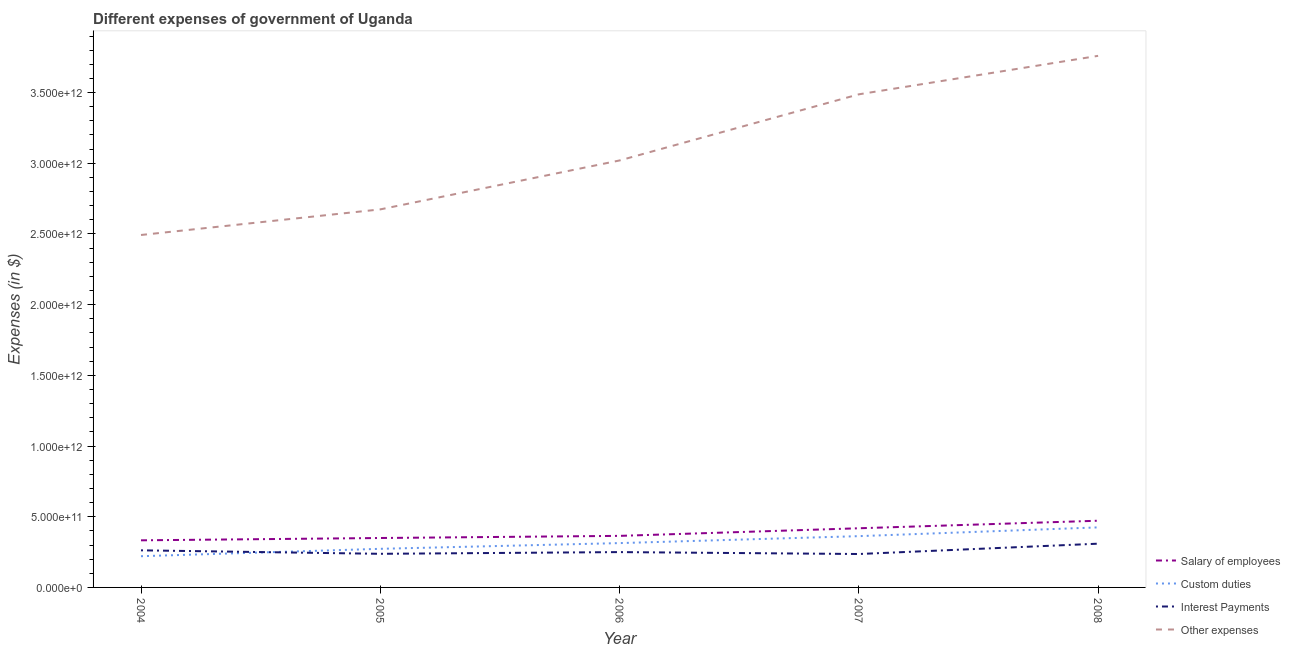How many different coloured lines are there?
Give a very brief answer. 4. Does the line corresponding to amount spent on salary of employees intersect with the line corresponding to amount spent on interest payments?
Your answer should be compact. No. What is the amount spent on other expenses in 2008?
Ensure brevity in your answer.  3.76e+12. Across all years, what is the maximum amount spent on other expenses?
Provide a succinct answer. 3.76e+12. Across all years, what is the minimum amount spent on custom duties?
Your answer should be very brief. 2.21e+11. In which year was the amount spent on salary of employees maximum?
Offer a very short reply. 2008. In which year was the amount spent on other expenses minimum?
Give a very brief answer. 2004. What is the total amount spent on salary of employees in the graph?
Ensure brevity in your answer.  1.94e+12. What is the difference between the amount spent on salary of employees in 2006 and that in 2008?
Offer a very short reply. -1.07e+11. What is the difference between the amount spent on custom duties in 2006 and the amount spent on other expenses in 2005?
Your answer should be very brief. -2.36e+12. What is the average amount spent on salary of employees per year?
Provide a short and direct response. 3.88e+11. In the year 2005, what is the difference between the amount spent on interest payments and amount spent on other expenses?
Ensure brevity in your answer.  -2.44e+12. In how many years, is the amount spent on interest payments greater than 700000000000 $?
Offer a terse response. 0. What is the ratio of the amount spent on interest payments in 2004 to that in 2005?
Your answer should be very brief. 1.1. Is the amount spent on other expenses in 2004 less than that in 2005?
Ensure brevity in your answer.  Yes. What is the difference between the highest and the second highest amount spent on interest payments?
Provide a short and direct response. 4.70e+1. What is the difference between the highest and the lowest amount spent on custom duties?
Make the answer very short. 2.04e+11. In how many years, is the amount spent on custom duties greater than the average amount spent on custom duties taken over all years?
Ensure brevity in your answer.  2. Is it the case that in every year, the sum of the amount spent on custom duties and amount spent on other expenses is greater than the sum of amount spent on interest payments and amount spent on salary of employees?
Keep it short and to the point. Yes. Does the amount spent on custom duties monotonically increase over the years?
Your answer should be compact. Yes. Is the amount spent on custom duties strictly greater than the amount spent on other expenses over the years?
Give a very brief answer. No. Is the amount spent on interest payments strictly less than the amount spent on other expenses over the years?
Provide a succinct answer. Yes. How many lines are there?
Offer a terse response. 4. How many years are there in the graph?
Make the answer very short. 5. What is the difference between two consecutive major ticks on the Y-axis?
Make the answer very short. 5.00e+11. Are the values on the major ticks of Y-axis written in scientific E-notation?
Your response must be concise. Yes. Does the graph contain any zero values?
Your answer should be very brief. No. Where does the legend appear in the graph?
Offer a terse response. Bottom right. How are the legend labels stacked?
Your answer should be very brief. Vertical. What is the title of the graph?
Give a very brief answer. Different expenses of government of Uganda. What is the label or title of the X-axis?
Your response must be concise. Year. What is the label or title of the Y-axis?
Offer a terse response. Expenses (in $). What is the Expenses (in $) in Salary of employees in 2004?
Offer a terse response. 3.33e+11. What is the Expenses (in $) of Custom duties in 2004?
Give a very brief answer. 2.21e+11. What is the Expenses (in $) of Interest Payments in 2004?
Give a very brief answer. 2.62e+11. What is the Expenses (in $) of Other expenses in 2004?
Ensure brevity in your answer.  2.49e+12. What is the Expenses (in $) in Salary of employees in 2005?
Ensure brevity in your answer.  3.50e+11. What is the Expenses (in $) of Custom duties in 2005?
Your answer should be very brief. 2.73e+11. What is the Expenses (in $) of Interest Payments in 2005?
Ensure brevity in your answer.  2.38e+11. What is the Expenses (in $) of Other expenses in 2005?
Your answer should be compact. 2.67e+12. What is the Expenses (in $) of Salary of employees in 2006?
Your answer should be very brief. 3.65e+11. What is the Expenses (in $) of Custom duties in 2006?
Ensure brevity in your answer.  3.14e+11. What is the Expenses (in $) of Interest Payments in 2006?
Your answer should be compact. 2.50e+11. What is the Expenses (in $) of Other expenses in 2006?
Offer a terse response. 3.02e+12. What is the Expenses (in $) of Salary of employees in 2007?
Your answer should be compact. 4.18e+11. What is the Expenses (in $) of Custom duties in 2007?
Offer a terse response. 3.63e+11. What is the Expenses (in $) in Interest Payments in 2007?
Your answer should be compact. 2.36e+11. What is the Expenses (in $) of Other expenses in 2007?
Give a very brief answer. 3.49e+12. What is the Expenses (in $) in Salary of employees in 2008?
Your response must be concise. 4.72e+11. What is the Expenses (in $) of Custom duties in 2008?
Offer a very short reply. 4.25e+11. What is the Expenses (in $) in Interest Payments in 2008?
Your response must be concise. 3.09e+11. What is the Expenses (in $) of Other expenses in 2008?
Ensure brevity in your answer.  3.76e+12. Across all years, what is the maximum Expenses (in $) of Salary of employees?
Keep it short and to the point. 4.72e+11. Across all years, what is the maximum Expenses (in $) in Custom duties?
Ensure brevity in your answer.  4.25e+11. Across all years, what is the maximum Expenses (in $) of Interest Payments?
Give a very brief answer. 3.09e+11. Across all years, what is the maximum Expenses (in $) in Other expenses?
Offer a terse response. 3.76e+12. Across all years, what is the minimum Expenses (in $) of Salary of employees?
Make the answer very short. 3.33e+11. Across all years, what is the minimum Expenses (in $) of Custom duties?
Ensure brevity in your answer.  2.21e+11. Across all years, what is the minimum Expenses (in $) of Interest Payments?
Offer a terse response. 2.36e+11. Across all years, what is the minimum Expenses (in $) in Other expenses?
Keep it short and to the point. 2.49e+12. What is the total Expenses (in $) in Salary of employees in the graph?
Ensure brevity in your answer.  1.94e+12. What is the total Expenses (in $) in Custom duties in the graph?
Provide a succinct answer. 1.59e+12. What is the total Expenses (in $) of Interest Payments in the graph?
Provide a short and direct response. 1.30e+12. What is the total Expenses (in $) of Other expenses in the graph?
Offer a terse response. 1.54e+13. What is the difference between the Expenses (in $) of Salary of employees in 2004 and that in 2005?
Your answer should be compact. -1.64e+1. What is the difference between the Expenses (in $) of Custom duties in 2004 and that in 2005?
Your response must be concise. -5.22e+1. What is the difference between the Expenses (in $) of Interest Payments in 2004 and that in 2005?
Make the answer very short. 2.46e+1. What is the difference between the Expenses (in $) of Other expenses in 2004 and that in 2005?
Offer a very short reply. -1.81e+11. What is the difference between the Expenses (in $) in Salary of employees in 2004 and that in 2006?
Keep it short and to the point. -3.15e+1. What is the difference between the Expenses (in $) of Custom duties in 2004 and that in 2006?
Provide a succinct answer. -9.27e+1. What is the difference between the Expenses (in $) of Interest Payments in 2004 and that in 2006?
Provide a succinct answer. 1.25e+1. What is the difference between the Expenses (in $) of Other expenses in 2004 and that in 2006?
Offer a terse response. -5.27e+11. What is the difference between the Expenses (in $) in Salary of employees in 2004 and that in 2007?
Offer a very short reply. -8.53e+1. What is the difference between the Expenses (in $) of Custom duties in 2004 and that in 2007?
Keep it short and to the point. -1.42e+11. What is the difference between the Expenses (in $) of Interest Payments in 2004 and that in 2007?
Your answer should be very brief. 2.61e+1. What is the difference between the Expenses (in $) in Other expenses in 2004 and that in 2007?
Your answer should be very brief. -9.95e+11. What is the difference between the Expenses (in $) of Salary of employees in 2004 and that in 2008?
Provide a succinct answer. -1.39e+11. What is the difference between the Expenses (in $) of Custom duties in 2004 and that in 2008?
Give a very brief answer. -2.04e+11. What is the difference between the Expenses (in $) in Interest Payments in 2004 and that in 2008?
Make the answer very short. -4.70e+1. What is the difference between the Expenses (in $) of Other expenses in 2004 and that in 2008?
Keep it short and to the point. -1.27e+12. What is the difference between the Expenses (in $) in Salary of employees in 2005 and that in 2006?
Give a very brief answer. -1.51e+1. What is the difference between the Expenses (in $) in Custom duties in 2005 and that in 2006?
Offer a very short reply. -4.04e+1. What is the difference between the Expenses (in $) of Interest Payments in 2005 and that in 2006?
Your answer should be very brief. -1.21e+1. What is the difference between the Expenses (in $) in Other expenses in 2005 and that in 2006?
Give a very brief answer. -3.46e+11. What is the difference between the Expenses (in $) of Salary of employees in 2005 and that in 2007?
Offer a very short reply. -6.89e+1. What is the difference between the Expenses (in $) in Custom duties in 2005 and that in 2007?
Offer a terse response. -8.96e+1. What is the difference between the Expenses (in $) in Interest Payments in 2005 and that in 2007?
Ensure brevity in your answer.  1.43e+09. What is the difference between the Expenses (in $) in Other expenses in 2005 and that in 2007?
Offer a very short reply. -8.14e+11. What is the difference between the Expenses (in $) of Salary of employees in 2005 and that in 2008?
Your answer should be compact. -1.22e+11. What is the difference between the Expenses (in $) in Custom duties in 2005 and that in 2008?
Keep it short and to the point. -1.52e+11. What is the difference between the Expenses (in $) of Interest Payments in 2005 and that in 2008?
Your answer should be very brief. -7.16e+1. What is the difference between the Expenses (in $) in Other expenses in 2005 and that in 2008?
Give a very brief answer. -1.09e+12. What is the difference between the Expenses (in $) in Salary of employees in 2006 and that in 2007?
Provide a succinct answer. -5.38e+1. What is the difference between the Expenses (in $) of Custom duties in 2006 and that in 2007?
Your response must be concise. -4.91e+1. What is the difference between the Expenses (in $) in Interest Payments in 2006 and that in 2007?
Provide a succinct answer. 1.36e+1. What is the difference between the Expenses (in $) in Other expenses in 2006 and that in 2007?
Give a very brief answer. -4.68e+11. What is the difference between the Expenses (in $) of Salary of employees in 2006 and that in 2008?
Make the answer very short. -1.07e+11. What is the difference between the Expenses (in $) in Custom duties in 2006 and that in 2008?
Your answer should be compact. -1.11e+11. What is the difference between the Expenses (in $) in Interest Payments in 2006 and that in 2008?
Your response must be concise. -5.95e+1. What is the difference between the Expenses (in $) of Other expenses in 2006 and that in 2008?
Provide a short and direct response. -7.40e+11. What is the difference between the Expenses (in $) in Salary of employees in 2007 and that in 2008?
Give a very brief answer. -5.33e+1. What is the difference between the Expenses (in $) of Custom duties in 2007 and that in 2008?
Give a very brief answer. -6.20e+1. What is the difference between the Expenses (in $) of Interest Payments in 2007 and that in 2008?
Your answer should be compact. -7.31e+1. What is the difference between the Expenses (in $) in Other expenses in 2007 and that in 2008?
Ensure brevity in your answer.  -2.72e+11. What is the difference between the Expenses (in $) of Salary of employees in 2004 and the Expenses (in $) of Custom duties in 2005?
Provide a succinct answer. 6.01e+1. What is the difference between the Expenses (in $) of Salary of employees in 2004 and the Expenses (in $) of Interest Payments in 2005?
Offer a terse response. 9.54e+1. What is the difference between the Expenses (in $) of Salary of employees in 2004 and the Expenses (in $) of Other expenses in 2005?
Your answer should be compact. -2.34e+12. What is the difference between the Expenses (in $) in Custom duties in 2004 and the Expenses (in $) in Interest Payments in 2005?
Provide a succinct answer. -1.69e+1. What is the difference between the Expenses (in $) of Custom duties in 2004 and the Expenses (in $) of Other expenses in 2005?
Give a very brief answer. -2.45e+12. What is the difference between the Expenses (in $) in Interest Payments in 2004 and the Expenses (in $) in Other expenses in 2005?
Make the answer very short. -2.41e+12. What is the difference between the Expenses (in $) of Salary of employees in 2004 and the Expenses (in $) of Custom duties in 2006?
Give a very brief answer. 1.97e+1. What is the difference between the Expenses (in $) in Salary of employees in 2004 and the Expenses (in $) in Interest Payments in 2006?
Give a very brief answer. 8.33e+1. What is the difference between the Expenses (in $) of Salary of employees in 2004 and the Expenses (in $) of Other expenses in 2006?
Ensure brevity in your answer.  -2.69e+12. What is the difference between the Expenses (in $) in Custom duties in 2004 and the Expenses (in $) in Interest Payments in 2006?
Offer a terse response. -2.90e+1. What is the difference between the Expenses (in $) in Custom duties in 2004 and the Expenses (in $) in Other expenses in 2006?
Your answer should be very brief. -2.80e+12. What is the difference between the Expenses (in $) in Interest Payments in 2004 and the Expenses (in $) in Other expenses in 2006?
Your answer should be compact. -2.76e+12. What is the difference between the Expenses (in $) of Salary of employees in 2004 and the Expenses (in $) of Custom duties in 2007?
Give a very brief answer. -2.95e+1. What is the difference between the Expenses (in $) in Salary of employees in 2004 and the Expenses (in $) in Interest Payments in 2007?
Offer a terse response. 9.69e+1. What is the difference between the Expenses (in $) of Salary of employees in 2004 and the Expenses (in $) of Other expenses in 2007?
Offer a very short reply. -3.15e+12. What is the difference between the Expenses (in $) in Custom duties in 2004 and the Expenses (in $) in Interest Payments in 2007?
Provide a succinct answer. -1.55e+1. What is the difference between the Expenses (in $) in Custom duties in 2004 and the Expenses (in $) in Other expenses in 2007?
Offer a terse response. -3.27e+12. What is the difference between the Expenses (in $) in Interest Payments in 2004 and the Expenses (in $) in Other expenses in 2007?
Give a very brief answer. -3.23e+12. What is the difference between the Expenses (in $) in Salary of employees in 2004 and the Expenses (in $) in Custom duties in 2008?
Give a very brief answer. -9.15e+1. What is the difference between the Expenses (in $) in Salary of employees in 2004 and the Expenses (in $) in Interest Payments in 2008?
Offer a very short reply. 2.38e+1. What is the difference between the Expenses (in $) in Salary of employees in 2004 and the Expenses (in $) in Other expenses in 2008?
Keep it short and to the point. -3.43e+12. What is the difference between the Expenses (in $) in Custom duties in 2004 and the Expenses (in $) in Interest Payments in 2008?
Your response must be concise. -8.86e+1. What is the difference between the Expenses (in $) in Custom duties in 2004 and the Expenses (in $) in Other expenses in 2008?
Your answer should be very brief. -3.54e+12. What is the difference between the Expenses (in $) in Interest Payments in 2004 and the Expenses (in $) in Other expenses in 2008?
Your answer should be very brief. -3.50e+12. What is the difference between the Expenses (in $) in Salary of employees in 2005 and the Expenses (in $) in Custom duties in 2006?
Your answer should be compact. 3.60e+1. What is the difference between the Expenses (in $) of Salary of employees in 2005 and the Expenses (in $) of Interest Payments in 2006?
Your response must be concise. 9.97e+1. What is the difference between the Expenses (in $) of Salary of employees in 2005 and the Expenses (in $) of Other expenses in 2006?
Provide a succinct answer. -2.67e+12. What is the difference between the Expenses (in $) of Custom duties in 2005 and the Expenses (in $) of Interest Payments in 2006?
Provide a succinct answer. 2.32e+1. What is the difference between the Expenses (in $) in Custom duties in 2005 and the Expenses (in $) in Other expenses in 2006?
Your answer should be very brief. -2.75e+12. What is the difference between the Expenses (in $) in Interest Payments in 2005 and the Expenses (in $) in Other expenses in 2006?
Offer a terse response. -2.78e+12. What is the difference between the Expenses (in $) in Salary of employees in 2005 and the Expenses (in $) in Custom duties in 2007?
Ensure brevity in your answer.  -1.31e+1. What is the difference between the Expenses (in $) of Salary of employees in 2005 and the Expenses (in $) of Interest Payments in 2007?
Offer a terse response. 1.13e+11. What is the difference between the Expenses (in $) in Salary of employees in 2005 and the Expenses (in $) in Other expenses in 2007?
Offer a very short reply. -3.14e+12. What is the difference between the Expenses (in $) in Custom duties in 2005 and the Expenses (in $) in Interest Payments in 2007?
Keep it short and to the point. 3.68e+1. What is the difference between the Expenses (in $) in Custom duties in 2005 and the Expenses (in $) in Other expenses in 2007?
Give a very brief answer. -3.21e+12. What is the difference between the Expenses (in $) of Interest Payments in 2005 and the Expenses (in $) of Other expenses in 2007?
Ensure brevity in your answer.  -3.25e+12. What is the difference between the Expenses (in $) in Salary of employees in 2005 and the Expenses (in $) in Custom duties in 2008?
Provide a short and direct response. -7.51e+1. What is the difference between the Expenses (in $) of Salary of employees in 2005 and the Expenses (in $) of Interest Payments in 2008?
Make the answer very short. 4.02e+1. What is the difference between the Expenses (in $) of Salary of employees in 2005 and the Expenses (in $) of Other expenses in 2008?
Offer a terse response. -3.41e+12. What is the difference between the Expenses (in $) of Custom duties in 2005 and the Expenses (in $) of Interest Payments in 2008?
Offer a very short reply. -3.63e+1. What is the difference between the Expenses (in $) of Custom duties in 2005 and the Expenses (in $) of Other expenses in 2008?
Give a very brief answer. -3.49e+12. What is the difference between the Expenses (in $) in Interest Payments in 2005 and the Expenses (in $) in Other expenses in 2008?
Provide a short and direct response. -3.52e+12. What is the difference between the Expenses (in $) of Salary of employees in 2006 and the Expenses (in $) of Custom duties in 2007?
Provide a succinct answer. 1.98e+09. What is the difference between the Expenses (in $) of Salary of employees in 2006 and the Expenses (in $) of Interest Payments in 2007?
Make the answer very short. 1.28e+11. What is the difference between the Expenses (in $) of Salary of employees in 2006 and the Expenses (in $) of Other expenses in 2007?
Offer a very short reply. -3.12e+12. What is the difference between the Expenses (in $) of Custom duties in 2006 and the Expenses (in $) of Interest Payments in 2007?
Ensure brevity in your answer.  7.72e+1. What is the difference between the Expenses (in $) in Custom duties in 2006 and the Expenses (in $) in Other expenses in 2007?
Ensure brevity in your answer.  -3.17e+12. What is the difference between the Expenses (in $) of Interest Payments in 2006 and the Expenses (in $) of Other expenses in 2007?
Your response must be concise. -3.24e+12. What is the difference between the Expenses (in $) of Salary of employees in 2006 and the Expenses (in $) of Custom duties in 2008?
Ensure brevity in your answer.  -6.00e+1. What is the difference between the Expenses (in $) of Salary of employees in 2006 and the Expenses (in $) of Interest Payments in 2008?
Offer a very short reply. 5.53e+1. What is the difference between the Expenses (in $) of Salary of employees in 2006 and the Expenses (in $) of Other expenses in 2008?
Offer a very short reply. -3.40e+12. What is the difference between the Expenses (in $) of Custom duties in 2006 and the Expenses (in $) of Interest Payments in 2008?
Offer a terse response. 4.13e+09. What is the difference between the Expenses (in $) of Custom duties in 2006 and the Expenses (in $) of Other expenses in 2008?
Ensure brevity in your answer.  -3.45e+12. What is the difference between the Expenses (in $) of Interest Payments in 2006 and the Expenses (in $) of Other expenses in 2008?
Give a very brief answer. -3.51e+12. What is the difference between the Expenses (in $) in Salary of employees in 2007 and the Expenses (in $) in Custom duties in 2008?
Your answer should be compact. -6.22e+09. What is the difference between the Expenses (in $) of Salary of employees in 2007 and the Expenses (in $) of Interest Payments in 2008?
Provide a succinct answer. 1.09e+11. What is the difference between the Expenses (in $) of Salary of employees in 2007 and the Expenses (in $) of Other expenses in 2008?
Provide a short and direct response. -3.34e+12. What is the difference between the Expenses (in $) in Custom duties in 2007 and the Expenses (in $) in Interest Payments in 2008?
Ensure brevity in your answer.  5.33e+1. What is the difference between the Expenses (in $) of Custom duties in 2007 and the Expenses (in $) of Other expenses in 2008?
Provide a succinct answer. -3.40e+12. What is the difference between the Expenses (in $) of Interest Payments in 2007 and the Expenses (in $) of Other expenses in 2008?
Your answer should be very brief. -3.52e+12. What is the average Expenses (in $) in Salary of employees per year?
Your response must be concise. 3.88e+11. What is the average Expenses (in $) of Custom duties per year?
Keep it short and to the point. 3.19e+11. What is the average Expenses (in $) of Interest Payments per year?
Offer a very short reply. 2.59e+11. What is the average Expenses (in $) of Other expenses per year?
Your answer should be very brief. 3.09e+12. In the year 2004, what is the difference between the Expenses (in $) in Salary of employees and Expenses (in $) in Custom duties?
Make the answer very short. 1.12e+11. In the year 2004, what is the difference between the Expenses (in $) of Salary of employees and Expenses (in $) of Interest Payments?
Ensure brevity in your answer.  7.08e+1. In the year 2004, what is the difference between the Expenses (in $) of Salary of employees and Expenses (in $) of Other expenses?
Offer a terse response. -2.16e+12. In the year 2004, what is the difference between the Expenses (in $) of Custom duties and Expenses (in $) of Interest Payments?
Ensure brevity in your answer.  -4.16e+1. In the year 2004, what is the difference between the Expenses (in $) of Custom duties and Expenses (in $) of Other expenses?
Ensure brevity in your answer.  -2.27e+12. In the year 2004, what is the difference between the Expenses (in $) in Interest Payments and Expenses (in $) in Other expenses?
Provide a succinct answer. -2.23e+12. In the year 2005, what is the difference between the Expenses (in $) of Salary of employees and Expenses (in $) of Custom duties?
Your answer should be compact. 7.65e+1. In the year 2005, what is the difference between the Expenses (in $) in Salary of employees and Expenses (in $) in Interest Payments?
Provide a succinct answer. 1.12e+11. In the year 2005, what is the difference between the Expenses (in $) in Salary of employees and Expenses (in $) in Other expenses?
Make the answer very short. -2.32e+12. In the year 2005, what is the difference between the Expenses (in $) of Custom duties and Expenses (in $) of Interest Payments?
Offer a very short reply. 3.53e+1. In the year 2005, what is the difference between the Expenses (in $) of Custom duties and Expenses (in $) of Other expenses?
Keep it short and to the point. -2.40e+12. In the year 2005, what is the difference between the Expenses (in $) of Interest Payments and Expenses (in $) of Other expenses?
Your answer should be compact. -2.44e+12. In the year 2006, what is the difference between the Expenses (in $) of Salary of employees and Expenses (in $) of Custom duties?
Provide a succinct answer. 5.11e+1. In the year 2006, what is the difference between the Expenses (in $) of Salary of employees and Expenses (in $) of Interest Payments?
Provide a succinct answer. 1.15e+11. In the year 2006, what is the difference between the Expenses (in $) in Salary of employees and Expenses (in $) in Other expenses?
Give a very brief answer. -2.66e+12. In the year 2006, what is the difference between the Expenses (in $) in Custom duties and Expenses (in $) in Interest Payments?
Provide a short and direct response. 6.36e+1. In the year 2006, what is the difference between the Expenses (in $) in Custom duties and Expenses (in $) in Other expenses?
Your response must be concise. -2.71e+12. In the year 2006, what is the difference between the Expenses (in $) in Interest Payments and Expenses (in $) in Other expenses?
Give a very brief answer. -2.77e+12. In the year 2007, what is the difference between the Expenses (in $) of Salary of employees and Expenses (in $) of Custom duties?
Your answer should be compact. 5.58e+1. In the year 2007, what is the difference between the Expenses (in $) of Salary of employees and Expenses (in $) of Interest Payments?
Your answer should be compact. 1.82e+11. In the year 2007, what is the difference between the Expenses (in $) of Salary of employees and Expenses (in $) of Other expenses?
Ensure brevity in your answer.  -3.07e+12. In the year 2007, what is the difference between the Expenses (in $) in Custom duties and Expenses (in $) in Interest Payments?
Ensure brevity in your answer.  1.26e+11. In the year 2007, what is the difference between the Expenses (in $) in Custom duties and Expenses (in $) in Other expenses?
Make the answer very short. -3.13e+12. In the year 2007, what is the difference between the Expenses (in $) of Interest Payments and Expenses (in $) of Other expenses?
Offer a very short reply. -3.25e+12. In the year 2008, what is the difference between the Expenses (in $) of Salary of employees and Expenses (in $) of Custom duties?
Ensure brevity in your answer.  4.71e+1. In the year 2008, what is the difference between the Expenses (in $) in Salary of employees and Expenses (in $) in Interest Payments?
Keep it short and to the point. 1.62e+11. In the year 2008, what is the difference between the Expenses (in $) in Salary of employees and Expenses (in $) in Other expenses?
Ensure brevity in your answer.  -3.29e+12. In the year 2008, what is the difference between the Expenses (in $) in Custom duties and Expenses (in $) in Interest Payments?
Offer a very short reply. 1.15e+11. In the year 2008, what is the difference between the Expenses (in $) in Custom duties and Expenses (in $) in Other expenses?
Make the answer very short. -3.34e+12. In the year 2008, what is the difference between the Expenses (in $) in Interest Payments and Expenses (in $) in Other expenses?
Your response must be concise. -3.45e+12. What is the ratio of the Expenses (in $) in Salary of employees in 2004 to that in 2005?
Make the answer very short. 0.95. What is the ratio of the Expenses (in $) of Custom duties in 2004 to that in 2005?
Your answer should be compact. 0.81. What is the ratio of the Expenses (in $) in Interest Payments in 2004 to that in 2005?
Your answer should be compact. 1.1. What is the ratio of the Expenses (in $) in Other expenses in 2004 to that in 2005?
Your response must be concise. 0.93. What is the ratio of the Expenses (in $) of Salary of employees in 2004 to that in 2006?
Your response must be concise. 0.91. What is the ratio of the Expenses (in $) in Custom duties in 2004 to that in 2006?
Offer a very short reply. 0.7. What is the ratio of the Expenses (in $) of Interest Payments in 2004 to that in 2006?
Provide a succinct answer. 1.05. What is the ratio of the Expenses (in $) of Other expenses in 2004 to that in 2006?
Your answer should be very brief. 0.83. What is the ratio of the Expenses (in $) in Salary of employees in 2004 to that in 2007?
Offer a terse response. 0.8. What is the ratio of the Expenses (in $) of Custom duties in 2004 to that in 2007?
Provide a succinct answer. 0.61. What is the ratio of the Expenses (in $) of Interest Payments in 2004 to that in 2007?
Keep it short and to the point. 1.11. What is the ratio of the Expenses (in $) of Other expenses in 2004 to that in 2007?
Offer a very short reply. 0.71. What is the ratio of the Expenses (in $) in Salary of employees in 2004 to that in 2008?
Your answer should be very brief. 0.71. What is the ratio of the Expenses (in $) of Custom duties in 2004 to that in 2008?
Your answer should be very brief. 0.52. What is the ratio of the Expenses (in $) in Interest Payments in 2004 to that in 2008?
Offer a terse response. 0.85. What is the ratio of the Expenses (in $) of Other expenses in 2004 to that in 2008?
Your answer should be compact. 0.66. What is the ratio of the Expenses (in $) in Salary of employees in 2005 to that in 2006?
Your response must be concise. 0.96. What is the ratio of the Expenses (in $) of Custom duties in 2005 to that in 2006?
Give a very brief answer. 0.87. What is the ratio of the Expenses (in $) in Interest Payments in 2005 to that in 2006?
Make the answer very short. 0.95. What is the ratio of the Expenses (in $) of Other expenses in 2005 to that in 2006?
Your response must be concise. 0.89. What is the ratio of the Expenses (in $) of Salary of employees in 2005 to that in 2007?
Offer a very short reply. 0.84. What is the ratio of the Expenses (in $) in Custom duties in 2005 to that in 2007?
Offer a terse response. 0.75. What is the ratio of the Expenses (in $) of Interest Payments in 2005 to that in 2007?
Give a very brief answer. 1.01. What is the ratio of the Expenses (in $) of Other expenses in 2005 to that in 2007?
Your response must be concise. 0.77. What is the ratio of the Expenses (in $) of Salary of employees in 2005 to that in 2008?
Offer a very short reply. 0.74. What is the ratio of the Expenses (in $) in Custom duties in 2005 to that in 2008?
Ensure brevity in your answer.  0.64. What is the ratio of the Expenses (in $) of Interest Payments in 2005 to that in 2008?
Provide a succinct answer. 0.77. What is the ratio of the Expenses (in $) in Other expenses in 2005 to that in 2008?
Your answer should be compact. 0.71. What is the ratio of the Expenses (in $) in Salary of employees in 2006 to that in 2007?
Provide a succinct answer. 0.87. What is the ratio of the Expenses (in $) in Custom duties in 2006 to that in 2007?
Your answer should be compact. 0.86. What is the ratio of the Expenses (in $) of Interest Payments in 2006 to that in 2007?
Offer a very short reply. 1.06. What is the ratio of the Expenses (in $) in Other expenses in 2006 to that in 2007?
Keep it short and to the point. 0.87. What is the ratio of the Expenses (in $) in Salary of employees in 2006 to that in 2008?
Make the answer very short. 0.77. What is the ratio of the Expenses (in $) in Custom duties in 2006 to that in 2008?
Your answer should be very brief. 0.74. What is the ratio of the Expenses (in $) in Interest Payments in 2006 to that in 2008?
Offer a very short reply. 0.81. What is the ratio of the Expenses (in $) in Other expenses in 2006 to that in 2008?
Offer a very short reply. 0.8. What is the ratio of the Expenses (in $) of Salary of employees in 2007 to that in 2008?
Offer a terse response. 0.89. What is the ratio of the Expenses (in $) in Custom duties in 2007 to that in 2008?
Offer a terse response. 0.85. What is the ratio of the Expenses (in $) of Interest Payments in 2007 to that in 2008?
Keep it short and to the point. 0.76. What is the ratio of the Expenses (in $) of Other expenses in 2007 to that in 2008?
Your response must be concise. 0.93. What is the difference between the highest and the second highest Expenses (in $) in Salary of employees?
Provide a short and direct response. 5.33e+1. What is the difference between the highest and the second highest Expenses (in $) in Custom duties?
Your response must be concise. 6.20e+1. What is the difference between the highest and the second highest Expenses (in $) of Interest Payments?
Your answer should be compact. 4.70e+1. What is the difference between the highest and the second highest Expenses (in $) of Other expenses?
Give a very brief answer. 2.72e+11. What is the difference between the highest and the lowest Expenses (in $) in Salary of employees?
Your answer should be compact. 1.39e+11. What is the difference between the highest and the lowest Expenses (in $) of Custom duties?
Make the answer very short. 2.04e+11. What is the difference between the highest and the lowest Expenses (in $) of Interest Payments?
Provide a short and direct response. 7.31e+1. What is the difference between the highest and the lowest Expenses (in $) of Other expenses?
Make the answer very short. 1.27e+12. 